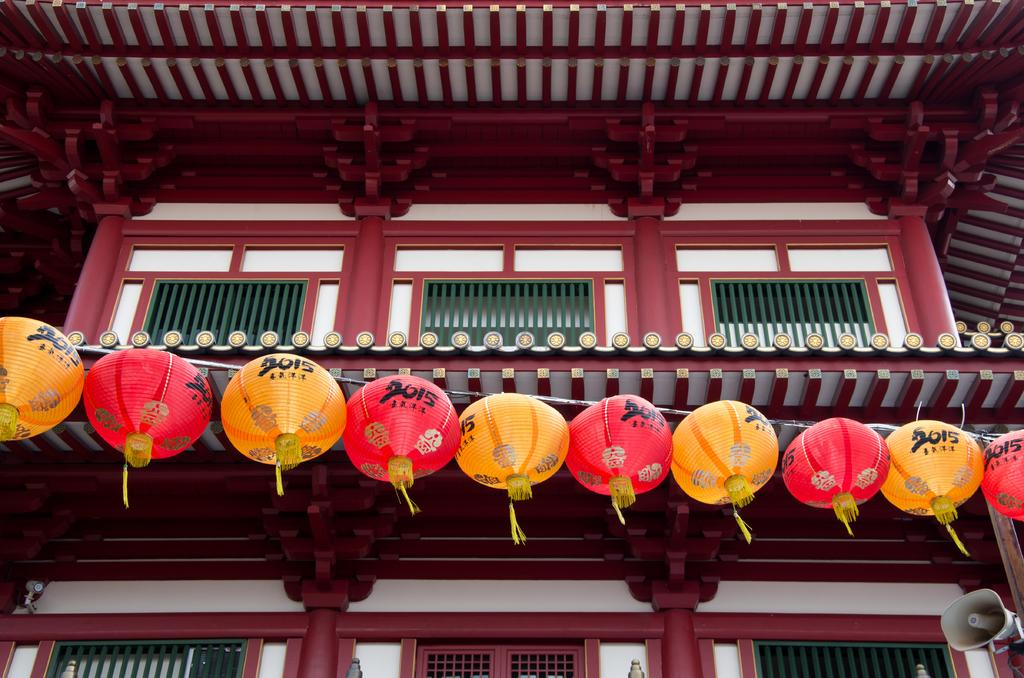<image>
Render a clear and concise summary of the photo. A row of Chinese lanterns with "2015" on them. 